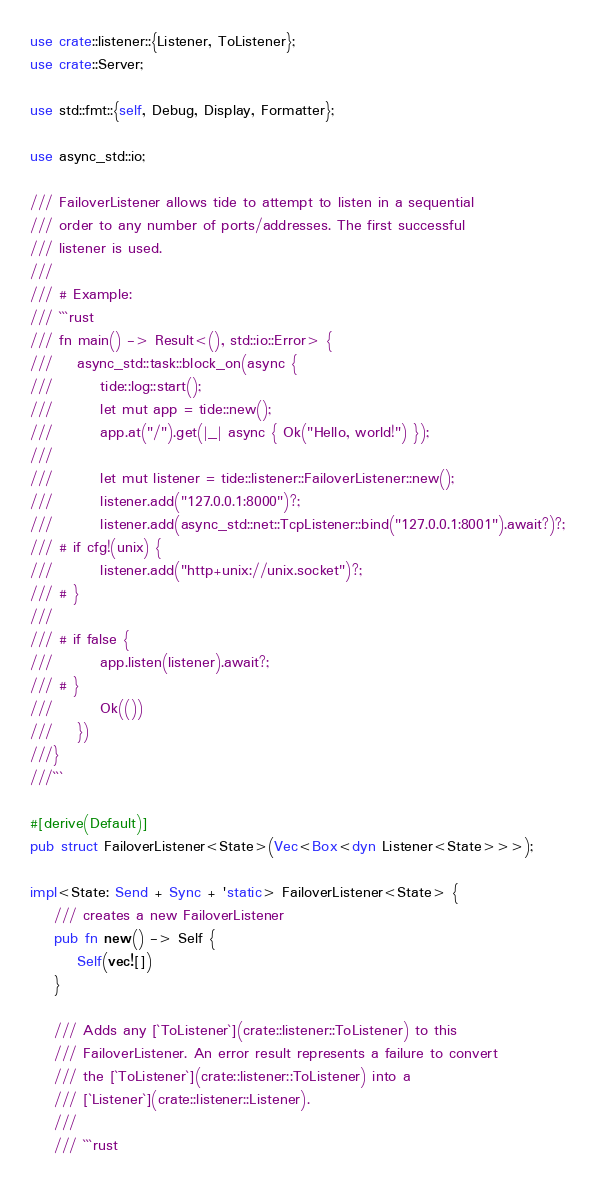<code> <loc_0><loc_0><loc_500><loc_500><_Rust_>use crate::listener::{Listener, ToListener};
use crate::Server;

use std::fmt::{self, Debug, Display, Formatter};

use async_std::io;

/// FailoverListener allows tide to attempt to listen in a sequential
/// order to any number of ports/addresses. The first successful
/// listener is used.
///
/// # Example:
/// ```rust
/// fn main() -> Result<(), std::io::Error> {
///    async_std::task::block_on(async {
///        tide::log::start();
///        let mut app = tide::new();
///        app.at("/").get(|_| async { Ok("Hello, world!") });
///
///        let mut listener = tide::listener::FailoverListener::new();
///        listener.add("127.0.0.1:8000")?;
///        listener.add(async_std::net::TcpListener::bind("127.0.0.1:8001").await?)?;
/// # if cfg!(unix) {
///        listener.add("http+unix://unix.socket")?;
/// # }
///    
/// # if false {
///        app.listen(listener).await?;
/// # }
///        Ok(())
///    })
///}
///```

#[derive(Default)]
pub struct FailoverListener<State>(Vec<Box<dyn Listener<State>>>);

impl<State: Send + Sync + 'static> FailoverListener<State> {
    /// creates a new FailoverListener
    pub fn new() -> Self {
        Self(vec![])
    }

    /// Adds any [`ToListener`](crate::listener::ToListener) to this
    /// FailoverListener. An error result represents a failure to convert
    /// the [`ToListener`](crate::listener::ToListener) into a
    /// [`Listener`](crate::listener::Listener).
    ///
    /// ```rust</code> 